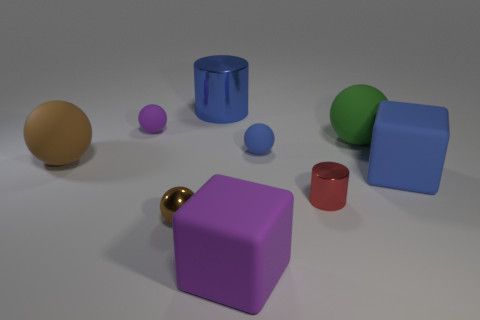What color is the large cylinder?
Offer a terse response. Blue. There is a tiny rubber thing that is on the right side of the blue metallic thing; is its color the same as the large cylinder?
Provide a short and direct response. Yes. What is the material of the small thing that is the same color as the large metallic thing?
Give a very brief answer. Rubber. How many other cylinders are the same color as the tiny cylinder?
Your answer should be compact. 0. Does the small brown object left of the purple rubber block have the same shape as the big green thing?
Provide a short and direct response. Yes. Is the number of tiny things that are on the left side of the big purple matte thing less than the number of small balls behind the small red metallic cylinder?
Give a very brief answer. No. What is the material of the block that is in front of the small brown metallic thing?
Ensure brevity in your answer.  Rubber. The rubber object that is the same color as the tiny metal ball is what size?
Give a very brief answer. Large. Are there any blue cylinders that have the same size as the green matte thing?
Offer a terse response. Yes. There is a small brown object; is its shape the same as the big blue thing in front of the tiny purple sphere?
Make the answer very short. No. 